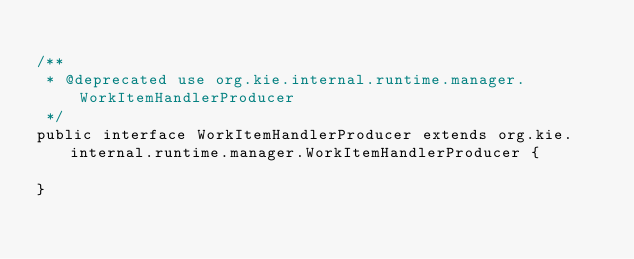Convert code to text. <code><loc_0><loc_0><loc_500><loc_500><_Java_>
/**
 * @deprecated use org.kie.internal.runtime.manager.WorkItemHandlerProducer
 */
public interface WorkItemHandlerProducer extends org.kie.internal.runtime.manager.WorkItemHandlerProducer {

}
</code> 